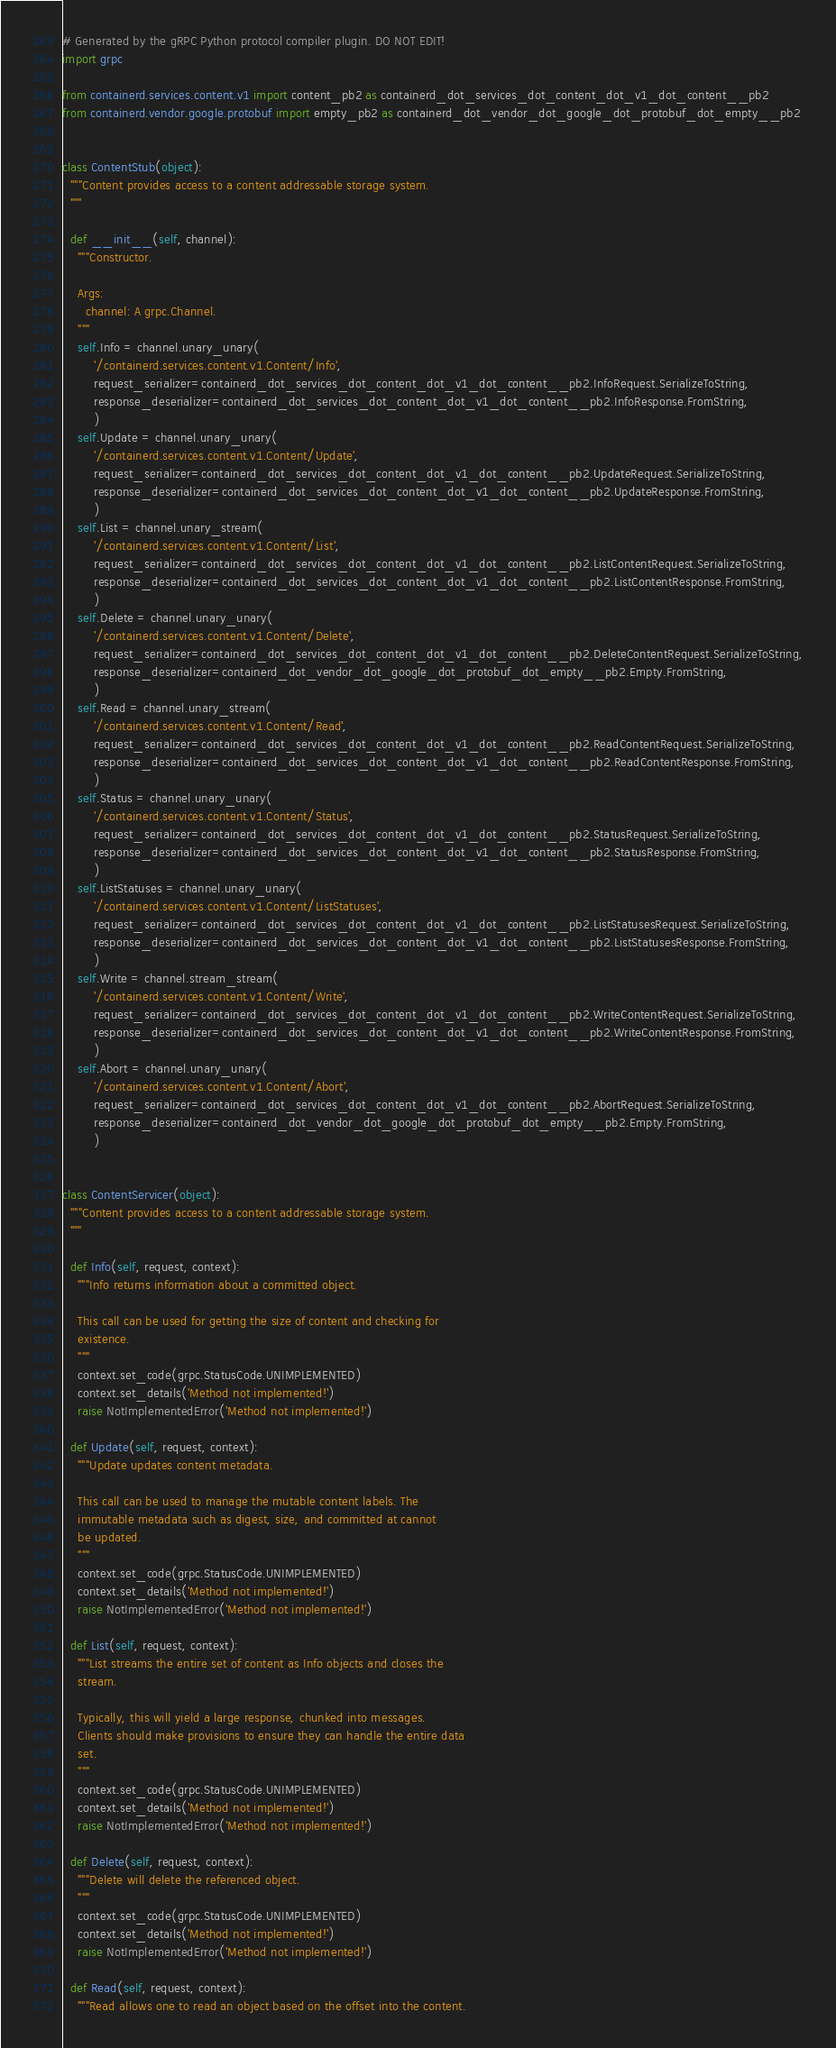Convert code to text. <code><loc_0><loc_0><loc_500><loc_500><_Python_># Generated by the gRPC Python protocol compiler plugin. DO NOT EDIT!
import grpc

from containerd.services.content.v1 import content_pb2 as containerd_dot_services_dot_content_dot_v1_dot_content__pb2
from containerd.vendor.google.protobuf import empty_pb2 as containerd_dot_vendor_dot_google_dot_protobuf_dot_empty__pb2


class ContentStub(object):
  """Content provides access to a content addressable storage system.
  """

  def __init__(self, channel):
    """Constructor.

    Args:
      channel: A grpc.Channel.
    """
    self.Info = channel.unary_unary(
        '/containerd.services.content.v1.Content/Info',
        request_serializer=containerd_dot_services_dot_content_dot_v1_dot_content__pb2.InfoRequest.SerializeToString,
        response_deserializer=containerd_dot_services_dot_content_dot_v1_dot_content__pb2.InfoResponse.FromString,
        )
    self.Update = channel.unary_unary(
        '/containerd.services.content.v1.Content/Update',
        request_serializer=containerd_dot_services_dot_content_dot_v1_dot_content__pb2.UpdateRequest.SerializeToString,
        response_deserializer=containerd_dot_services_dot_content_dot_v1_dot_content__pb2.UpdateResponse.FromString,
        )
    self.List = channel.unary_stream(
        '/containerd.services.content.v1.Content/List',
        request_serializer=containerd_dot_services_dot_content_dot_v1_dot_content__pb2.ListContentRequest.SerializeToString,
        response_deserializer=containerd_dot_services_dot_content_dot_v1_dot_content__pb2.ListContentResponse.FromString,
        )
    self.Delete = channel.unary_unary(
        '/containerd.services.content.v1.Content/Delete',
        request_serializer=containerd_dot_services_dot_content_dot_v1_dot_content__pb2.DeleteContentRequest.SerializeToString,
        response_deserializer=containerd_dot_vendor_dot_google_dot_protobuf_dot_empty__pb2.Empty.FromString,
        )
    self.Read = channel.unary_stream(
        '/containerd.services.content.v1.Content/Read',
        request_serializer=containerd_dot_services_dot_content_dot_v1_dot_content__pb2.ReadContentRequest.SerializeToString,
        response_deserializer=containerd_dot_services_dot_content_dot_v1_dot_content__pb2.ReadContentResponse.FromString,
        )
    self.Status = channel.unary_unary(
        '/containerd.services.content.v1.Content/Status',
        request_serializer=containerd_dot_services_dot_content_dot_v1_dot_content__pb2.StatusRequest.SerializeToString,
        response_deserializer=containerd_dot_services_dot_content_dot_v1_dot_content__pb2.StatusResponse.FromString,
        )
    self.ListStatuses = channel.unary_unary(
        '/containerd.services.content.v1.Content/ListStatuses',
        request_serializer=containerd_dot_services_dot_content_dot_v1_dot_content__pb2.ListStatusesRequest.SerializeToString,
        response_deserializer=containerd_dot_services_dot_content_dot_v1_dot_content__pb2.ListStatusesResponse.FromString,
        )
    self.Write = channel.stream_stream(
        '/containerd.services.content.v1.Content/Write',
        request_serializer=containerd_dot_services_dot_content_dot_v1_dot_content__pb2.WriteContentRequest.SerializeToString,
        response_deserializer=containerd_dot_services_dot_content_dot_v1_dot_content__pb2.WriteContentResponse.FromString,
        )
    self.Abort = channel.unary_unary(
        '/containerd.services.content.v1.Content/Abort',
        request_serializer=containerd_dot_services_dot_content_dot_v1_dot_content__pb2.AbortRequest.SerializeToString,
        response_deserializer=containerd_dot_vendor_dot_google_dot_protobuf_dot_empty__pb2.Empty.FromString,
        )


class ContentServicer(object):
  """Content provides access to a content addressable storage system.
  """

  def Info(self, request, context):
    """Info returns information about a committed object.

    This call can be used for getting the size of content and checking for
    existence.
    """
    context.set_code(grpc.StatusCode.UNIMPLEMENTED)
    context.set_details('Method not implemented!')
    raise NotImplementedError('Method not implemented!')

  def Update(self, request, context):
    """Update updates content metadata.

    This call can be used to manage the mutable content labels. The
    immutable metadata such as digest, size, and committed at cannot
    be updated.
    """
    context.set_code(grpc.StatusCode.UNIMPLEMENTED)
    context.set_details('Method not implemented!')
    raise NotImplementedError('Method not implemented!')

  def List(self, request, context):
    """List streams the entire set of content as Info objects and closes the
    stream.

    Typically, this will yield a large response, chunked into messages.
    Clients should make provisions to ensure they can handle the entire data
    set.
    """
    context.set_code(grpc.StatusCode.UNIMPLEMENTED)
    context.set_details('Method not implemented!')
    raise NotImplementedError('Method not implemented!')

  def Delete(self, request, context):
    """Delete will delete the referenced object.
    """
    context.set_code(grpc.StatusCode.UNIMPLEMENTED)
    context.set_details('Method not implemented!')
    raise NotImplementedError('Method not implemented!')

  def Read(self, request, context):
    """Read allows one to read an object based on the offset into the content.
</code> 